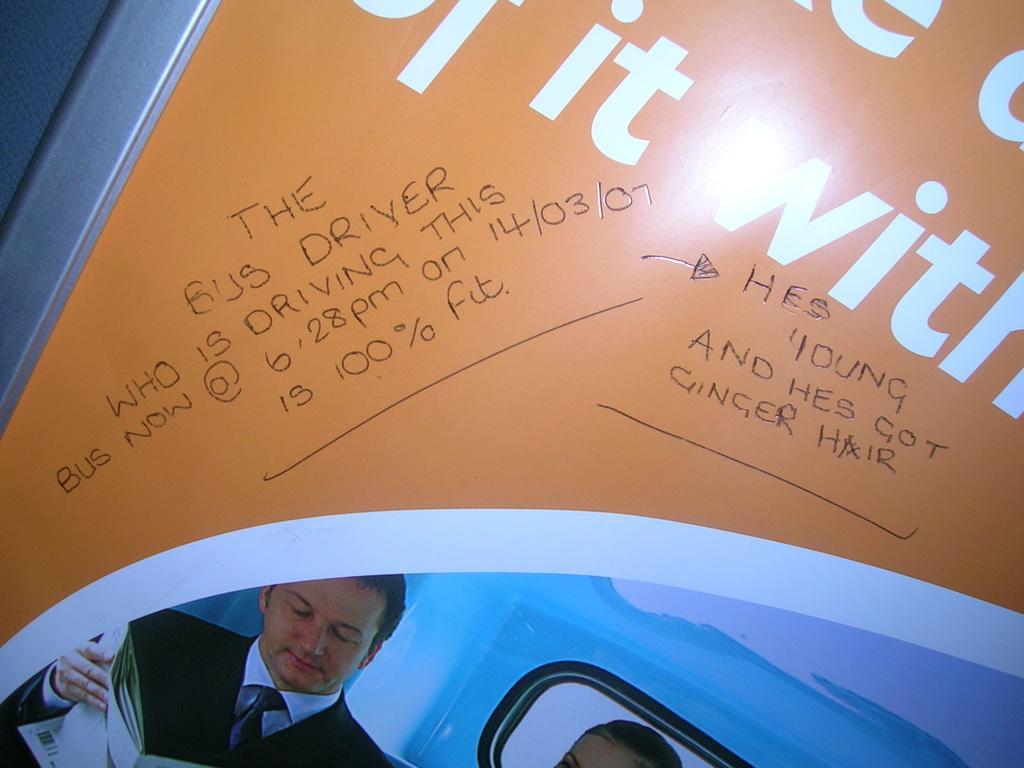In one or two sentences, can you explain what this image depicts? In this image I can see an orange and blue colour thing, on it I can see something is written and here I can see two persons. I can also see he is wearing formal dress and I can see he is holding few papers. 